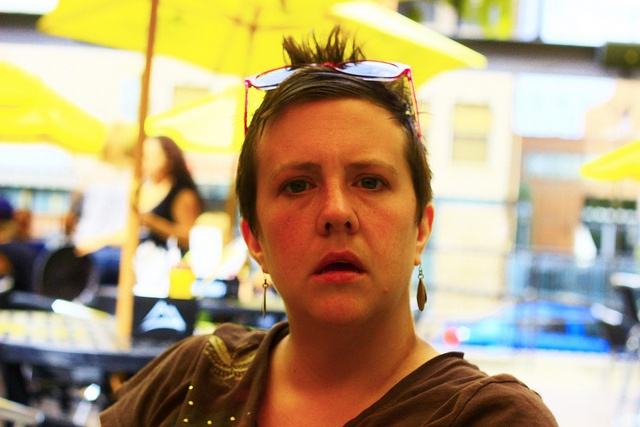Describe the objects in this image and their specific colors. I can see people in white, maroon, brown, black, and red tones, umbrella in white, yellow, beige, and khaki tones, dining table in white, ivory, black, and khaki tones, umbrella in white, yellow, khaki, and lightyellow tones, and car in white and lightblue tones in this image. 